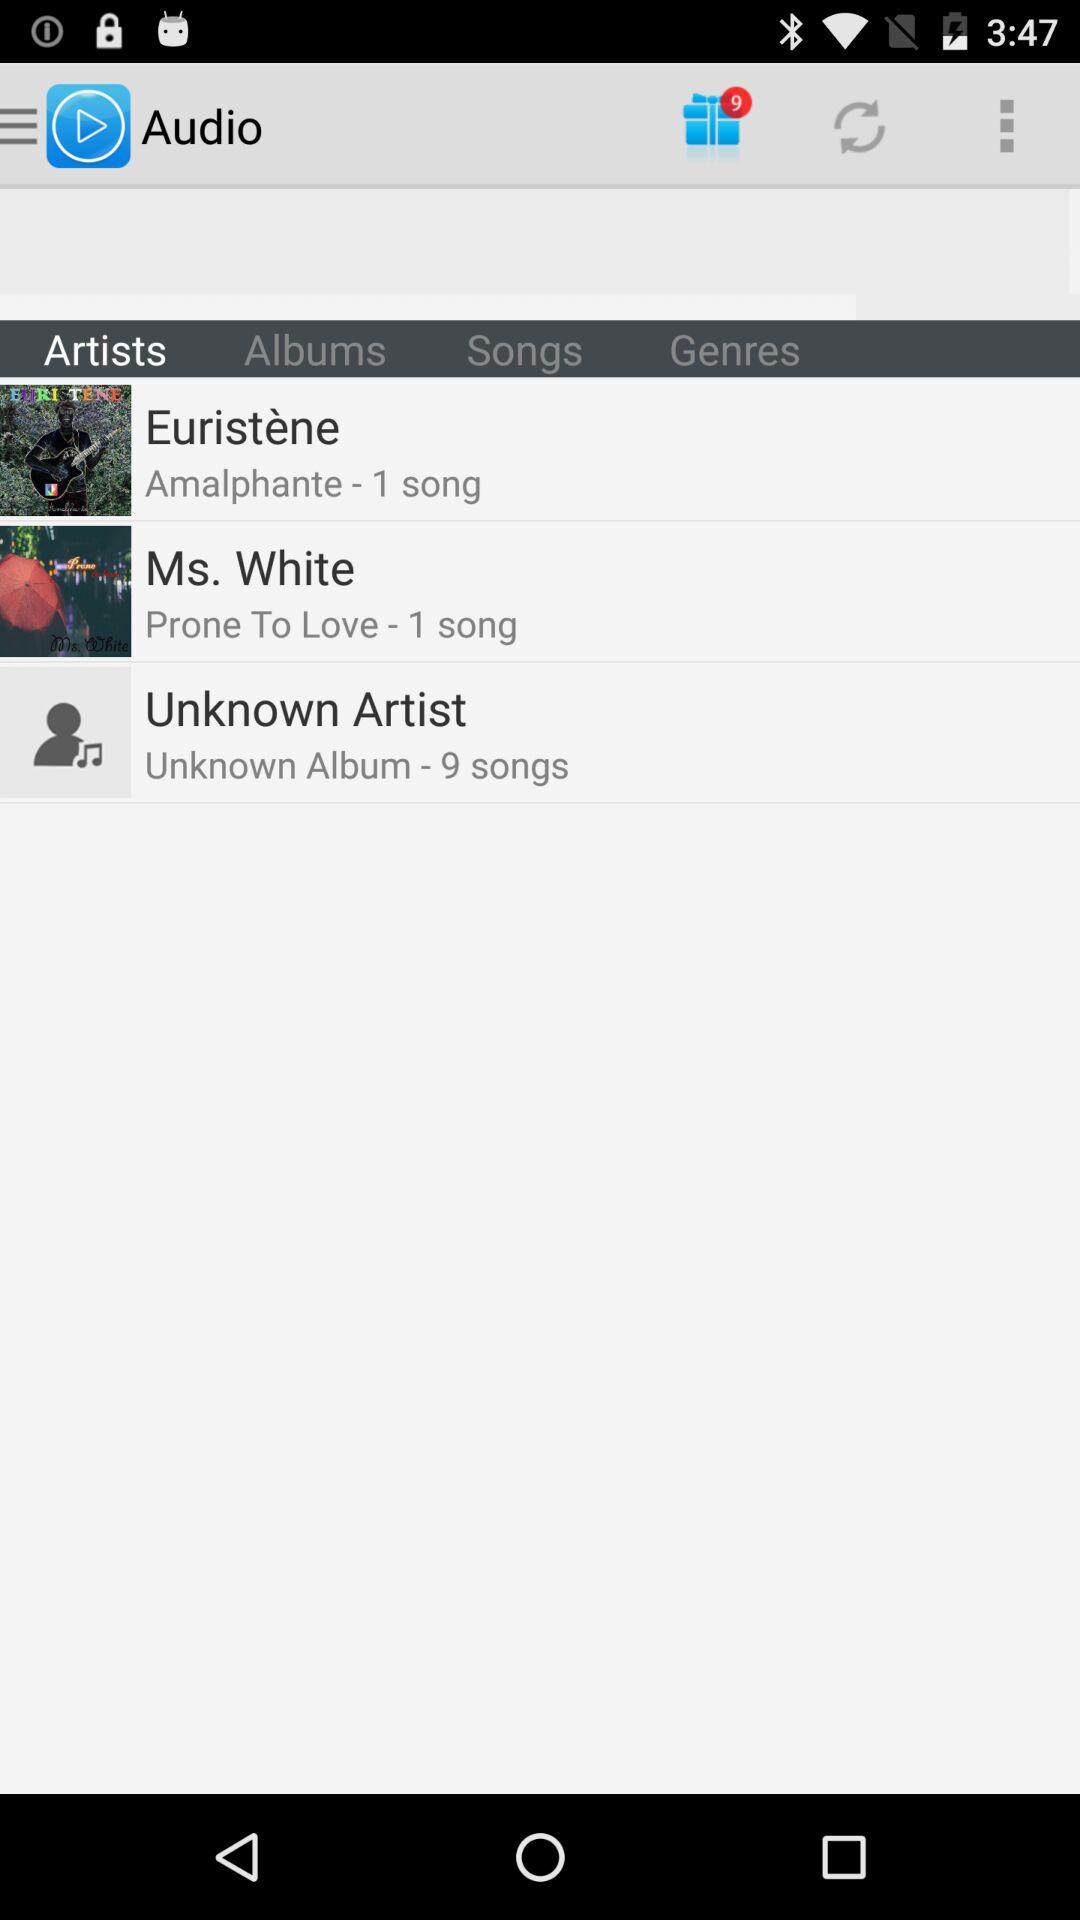How many songs are there by the unknown artist? There are 9 songs. 